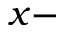Convert formula to latex. <formula><loc_0><loc_0><loc_500><loc_500>x -</formula> 